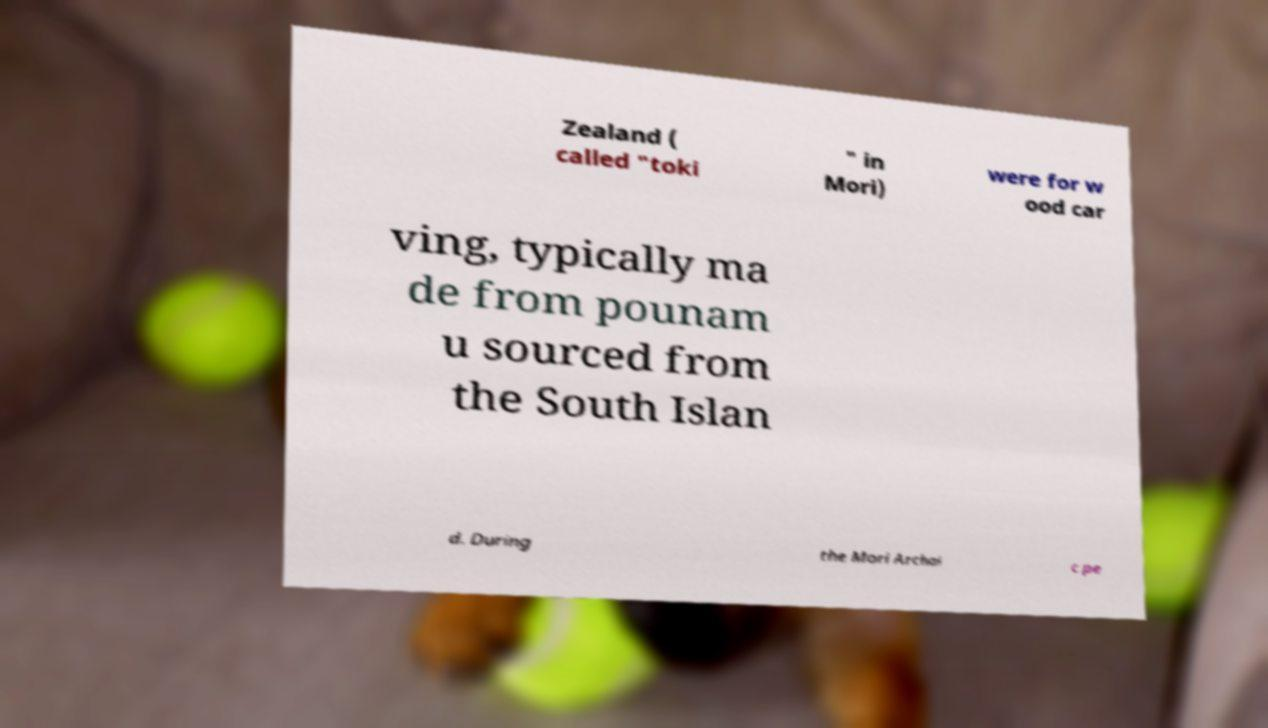I need the written content from this picture converted into text. Can you do that? Zealand ( called "toki " in Mori) were for w ood car ving, typically ma de from pounam u sourced from the South Islan d. During the Mori Archai c pe 